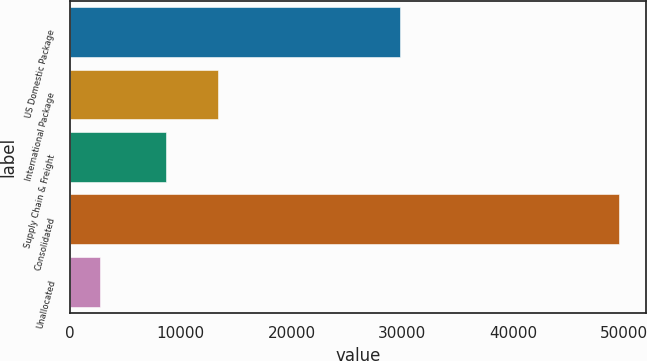<chart> <loc_0><loc_0><loc_500><loc_500><bar_chart><fcel>US Domestic Package<fcel>International Package<fcel>Supply Chain & Freight<fcel>Consolidated<fcel>Unallocated<nl><fcel>29742<fcel>13358.4<fcel>8670<fcel>49545<fcel>2661<nl></chart> 